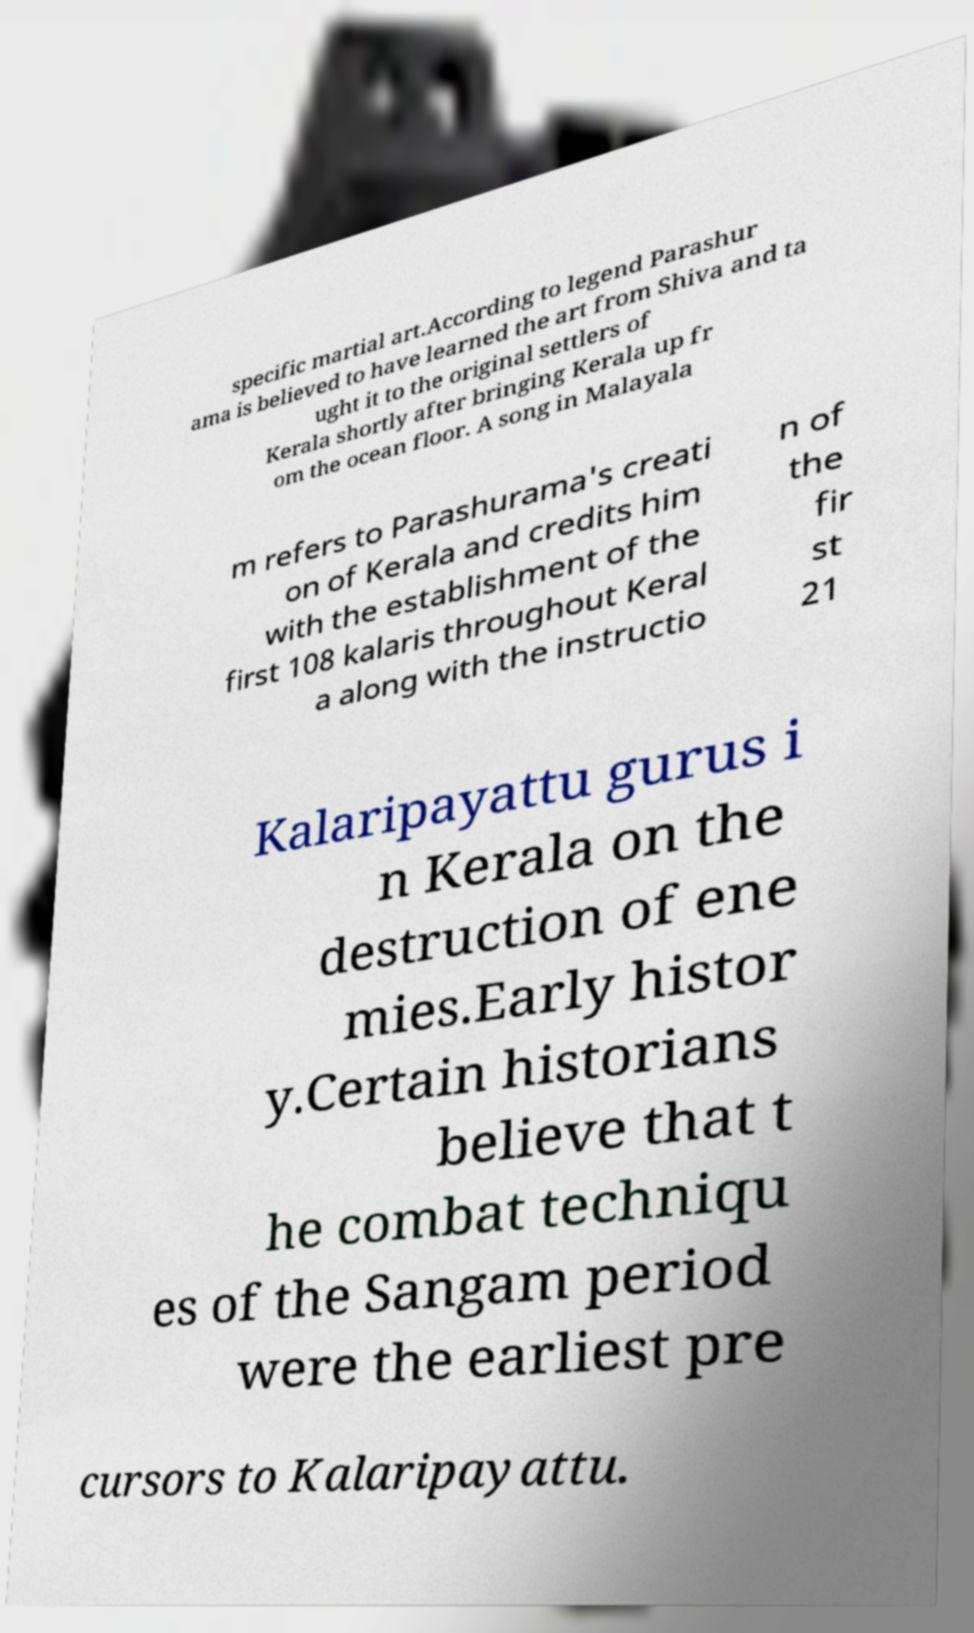Can you read and provide the text displayed in the image?This photo seems to have some interesting text. Can you extract and type it out for me? specific martial art.According to legend Parashur ama is believed to have learned the art from Shiva and ta ught it to the original settlers of Kerala shortly after bringing Kerala up fr om the ocean floor. A song in Malayala m refers to Parashurama's creati on of Kerala and credits him with the establishment of the first 108 kalaris throughout Keral a along with the instructio n of the fir st 21 Kalaripayattu gurus i n Kerala on the destruction of ene mies.Early histor y.Certain historians believe that t he combat techniqu es of the Sangam period were the earliest pre cursors to Kalaripayattu. 